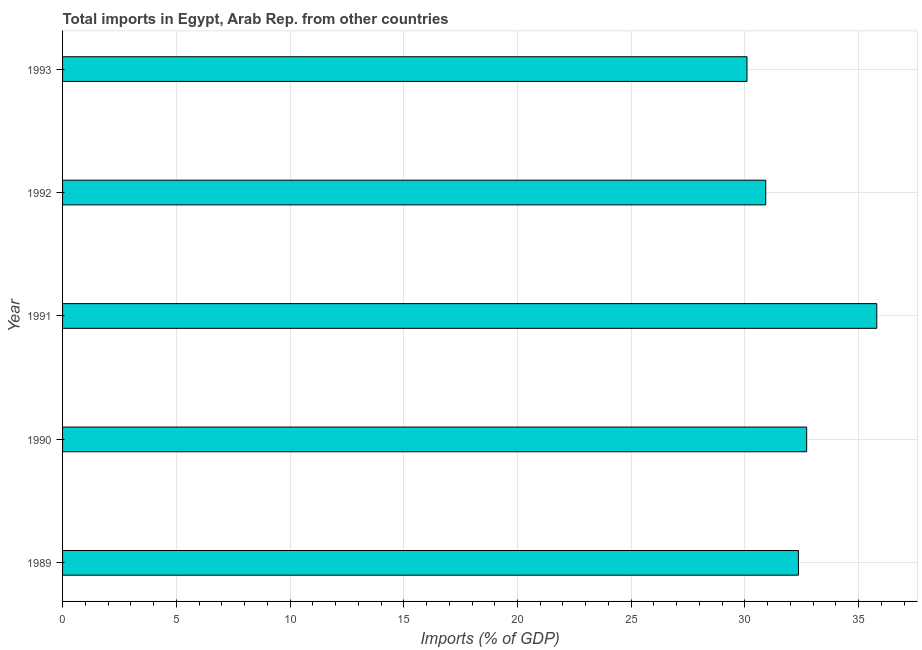Does the graph contain grids?
Provide a succinct answer. Yes. What is the title of the graph?
Provide a succinct answer. Total imports in Egypt, Arab Rep. from other countries. What is the label or title of the X-axis?
Your response must be concise. Imports (% of GDP). What is the total imports in 1989?
Make the answer very short. 32.35. Across all years, what is the maximum total imports?
Offer a terse response. 35.8. Across all years, what is the minimum total imports?
Keep it short and to the point. 30.09. In which year was the total imports minimum?
Offer a terse response. 1993. What is the sum of the total imports?
Provide a succinct answer. 161.86. What is the difference between the total imports in 1989 and 1992?
Ensure brevity in your answer.  1.44. What is the average total imports per year?
Your response must be concise. 32.37. What is the median total imports?
Ensure brevity in your answer.  32.35. In how many years, is the total imports greater than 24 %?
Offer a very short reply. 5. Do a majority of the years between 1991 and 1992 (inclusive) have total imports greater than 32 %?
Make the answer very short. No. What is the ratio of the total imports in 1989 to that in 1991?
Offer a terse response. 0.9. Is the difference between the total imports in 1989 and 1992 greater than the difference between any two years?
Offer a terse response. No. What is the difference between the highest and the second highest total imports?
Provide a short and direct response. 3.08. What is the difference between the highest and the lowest total imports?
Your answer should be compact. 5.71. How many bars are there?
Offer a very short reply. 5. Are all the bars in the graph horizontal?
Provide a succinct answer. Yes. How many years are there in the graph?
Provide a short and direct response. 5. What is the difference between two consecutive major ticks on the X-axis?
Offer a very short reply. 5. What is the Imports (% of GDP) in 1989?
Ensure brevity in your answer.  32.35. What is the Imports (% of GDP) of 1990?
Make the answer very short. 32.71. What is the Imports (% of GDP) in 1991?
Your response must be concise. 35.8. What is the Imports (% of GDP) of 1992?
Your response must be concise. 30.91. What is the Imports (% of GDP) of 1993?
Your response must be concise. 30.09. What is the difference between the Imports (% of GDP) in 1989 and 1990?
Provide a short and direct response. -0.36. What is the difference between the Imports (% of GDP) in 1989 and 1991?
Keep it short and to the point. -3.44. What is the difference between the Imports (% of GDP) in 1989 and 1992?
Give a very brief answer. 1.44. What is the difference between the Imports (% of GDP) in 1989 and 1993?
Offer a very short reply. 2.26. What is the difference between the Imports (% of GDP) in 1990 and 1991?
Provide a succinct answer. -3.08. What is the difference between the Imports (% of GDP) in 1990 and 1992?
Your answer should be very brief. 1.8. What is the difference between the Imports (% of GDP) in 1990 and 1993?
Ensure brevity in your answer.  2.62. What is the difference between the Imports (% of GDP) in 1991 and 1992?
Keep it short and to the point. 4.88. What is the difference between the Imports (% of GDP) in 1991 and 1993?
Your answer should be very brief. 5.71. What is the difference between the Imports (% of GDP) in 1992 and 1993?
Ensure brevity in your answer.  0.82. What is the ratio of the Imports (% of GDP) in 1989 to that in 1991?
Ensure brevity in your answer.  0.9. What is the ratio of the Imports (% of GDP) in 1989 to that in 1992?
Make the answer very short. 1.05. What is the ratio of the Imports (% of GDP) in 1989 to that in 1993?
Keep it short and to the point. 1.07. What is the ratio of the Imports (% of GDP) in 1990 to that in 1991?
Your answer should be compact. 0.91. What is the ratio of the Imports (% of GDP) in 1990 to that in 1992?
Offer a very short reply. 1.06. What is the ratio of the Imports (% of GDP) in 1990 to that in 1993?
Give a very brief answer. 1.09. What is the ratio of the Imports (% of GDP) in 1991 to that in 1992?
Provide a short and direct response. 1.16. What is the ratio of the Imports (% of GDP) in 1991 to that in 1993?
Make the answer very short. 1.19. 